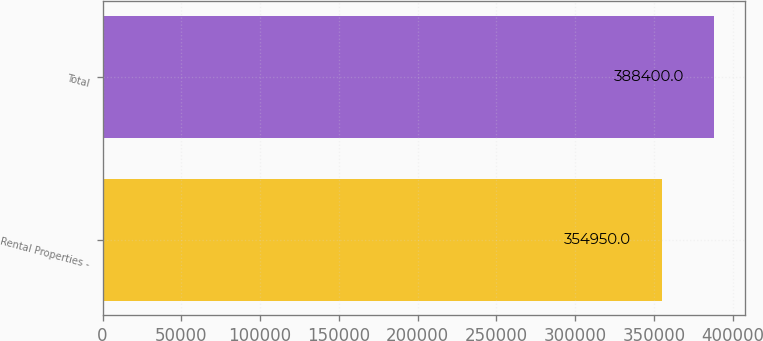Convert chart. <chart><loc_0><loc_0><loc_500><loc_500><bar_chart><fcel>Rental Properties -<fcel>Total<nl><fcel>354950<fcel>388400<nl></chart> 